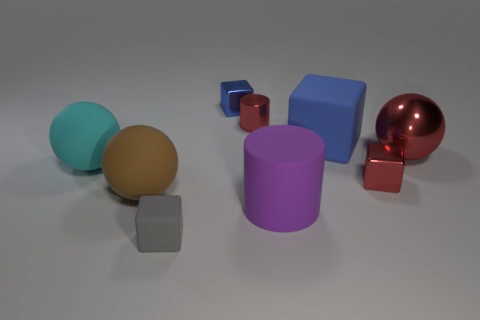Are there fewer blue rubber blocks than large red metallic blocks?
Offer a very short reply. No. There is a big matte cylinder; does it have the same color as the cube behind the large blue object?
Keep it short and to the point. No. Is the number of purple cylinders right of the purple rubber thing the same as the number of matte things on the right side of the tiny metal cylinder?
Keep it short and to the point. No. What number of big blue rubber objects have the same shape as the big cyan object?
Your response must be concise. 0. Is there a green object?
Keep it short and to the point. No. Is the small blue block made of the same material as the cylinder in front of the metal ball?
Offer a terse response. No. What is the material of the red block that is the same size as the blue shiny cube?
Provide a succinct answer. Metal. Is there a red cylinder that has the same material as the small blue block?
Your answer should be compact. Yes. Is there a small object that is behind the block to the left of the blue thing that is behind the blue matte object?
Ensure brevity in your answer.  Yes. What is the shape of the red thing that is the same size as the red shiny cylinder?
Your response must be concise. Cube. 